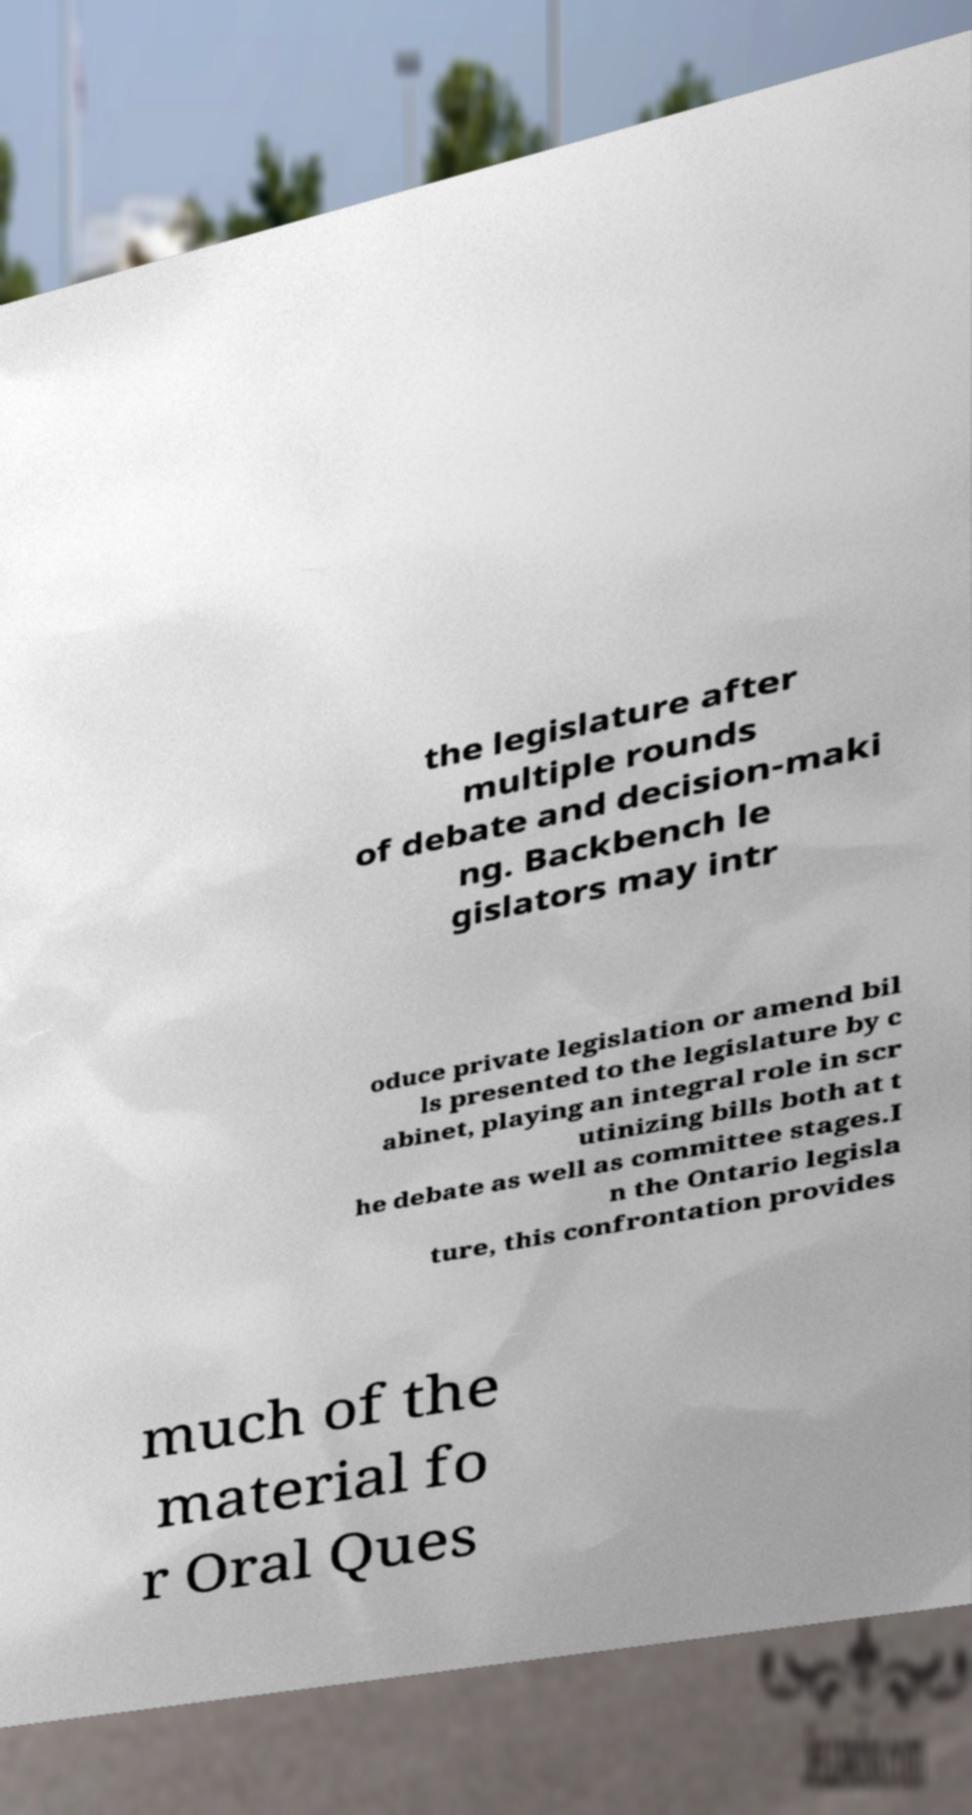What messages or text are displayed in this image? I need them in a readable, typed format. the legislature after multiple rounds of debate and decision-maki ng. Backbench le gislators may intr oduce private legislation or amend bil ls presented to the legislature by c abinet, playing an integral role in scr utinizing bills both at t he debate as well as committee stages.I n the Ontario legisla ture, this confrontation provides much of the material fo r Oral Ques 